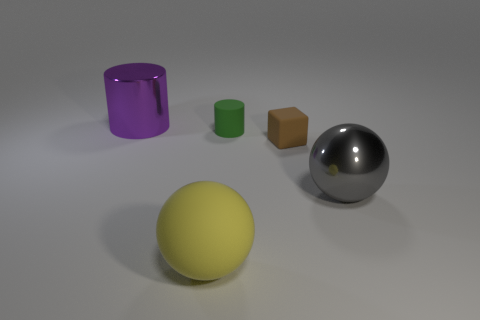Add 1 big metal things. How many objects exist? 6 Subtract all balls. How many objects are left? 3 Add 3 metallic objects. How many metallic objects are left? 5 Add 2 small metallic things. How many small metallic things exist? 2 Subtract 0 red spheres. How many objects are left? 5 Subtract all tiny green shiny blocks. Subtract all purple cylinders. How many objects are left? 4 